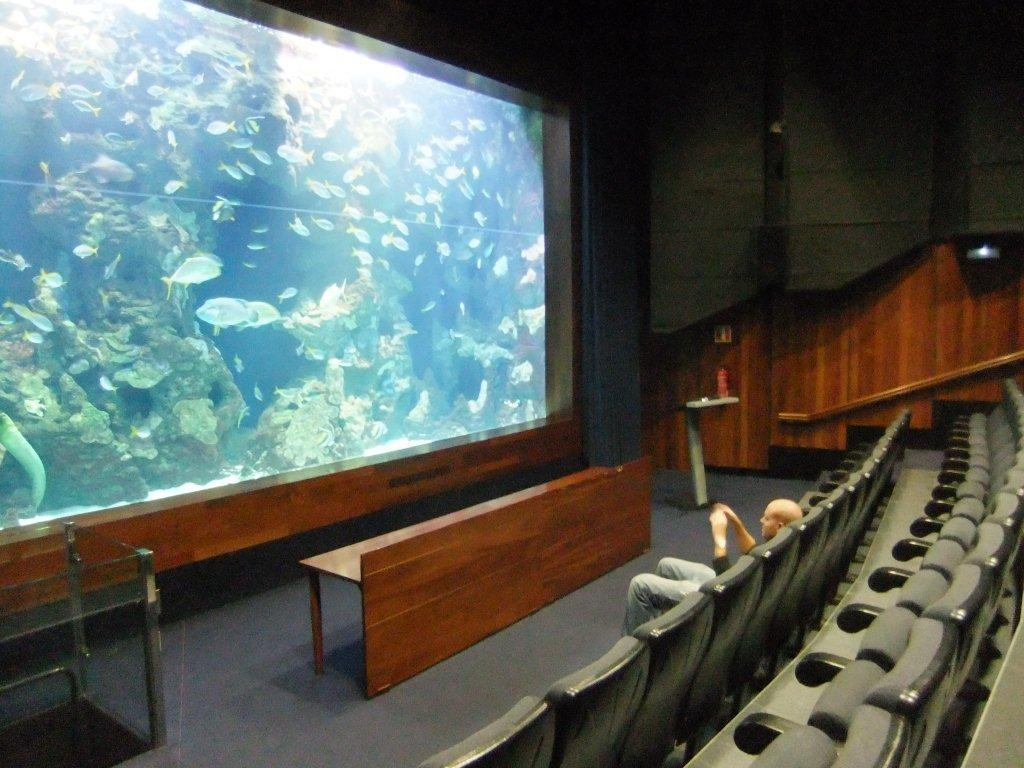What is being displayed on the screen in the image? There are fishes visible on a screen in the image. What type of furniture is present in the image? There is a wooden table and a chair in the image. Who is sitting on the chair in the image? A man is sitting on the chair in the image. What can be seen behind the man and the table in the image? There is a wall in the image. Can you tell me how many frogs are jumping on the wall in the image? There are no frogs present in the image; it features fishes on a screen and a man sitting on a chair. What type of room is shown in the image? The image does not show a room; it only shows a man sitting on a chair, a wooden table, a wall, and a screen with fishes. 